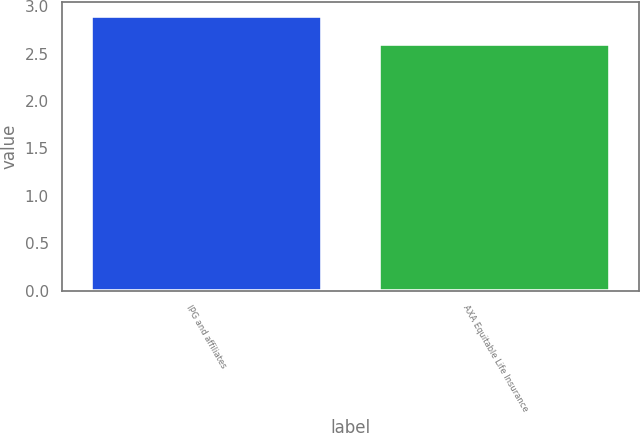Convert chart. <chart><loc_0><loc_0><loc_500><loc_500><bar_chart><fcel>IPG and affiliates<fcel>AXA Equitable Life Insurance<nl><fcel>2.9<fcel>2.6<nl></chart> 